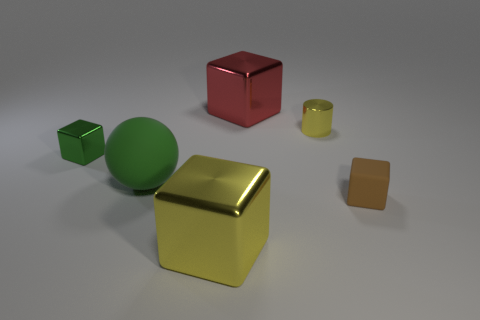Add 3 small green blocks. How many objects exist? 9 Subtract all balls. How many objects are left? 5 Add 2 metal things. How many metal things are left? 6 Add 4 yellow metal blocks. How many yellow metal blocks exist? 5 Subtract 1 green cubes. How many objects are left? 5 Subtract all tiny gray matte cylinders. Subtract all green balls. How many objects are left? 5 